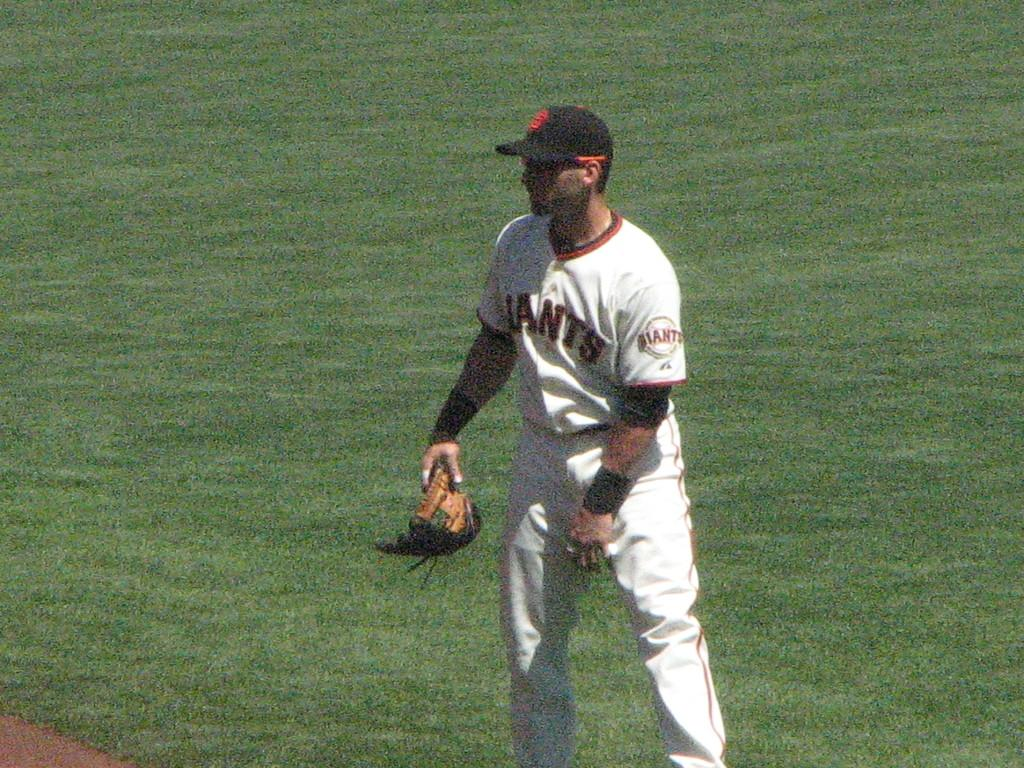<image>
Summarize the visual content of the image. A Giants player stands at the edge of the diamond  waiting to play. 